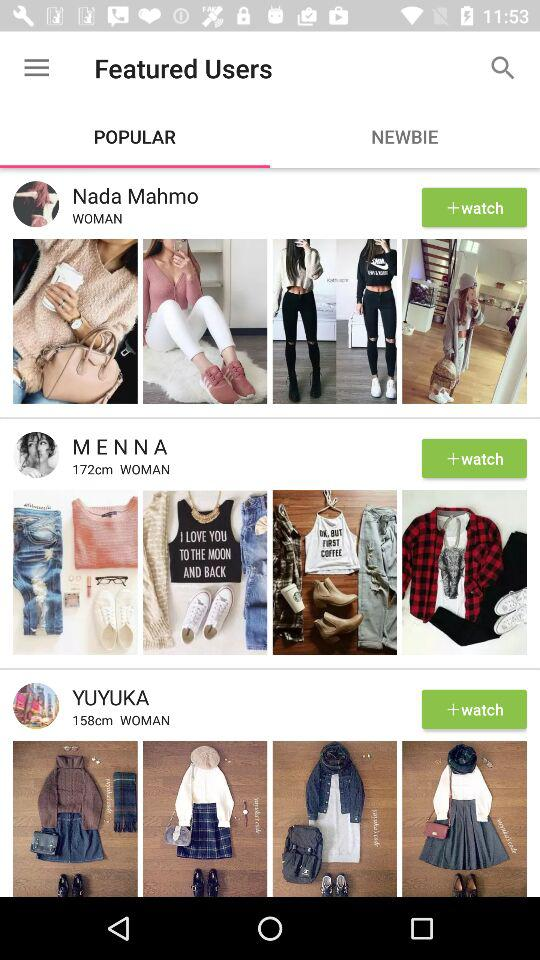Which tab am I on? You are on the "POPULAR" tab. 